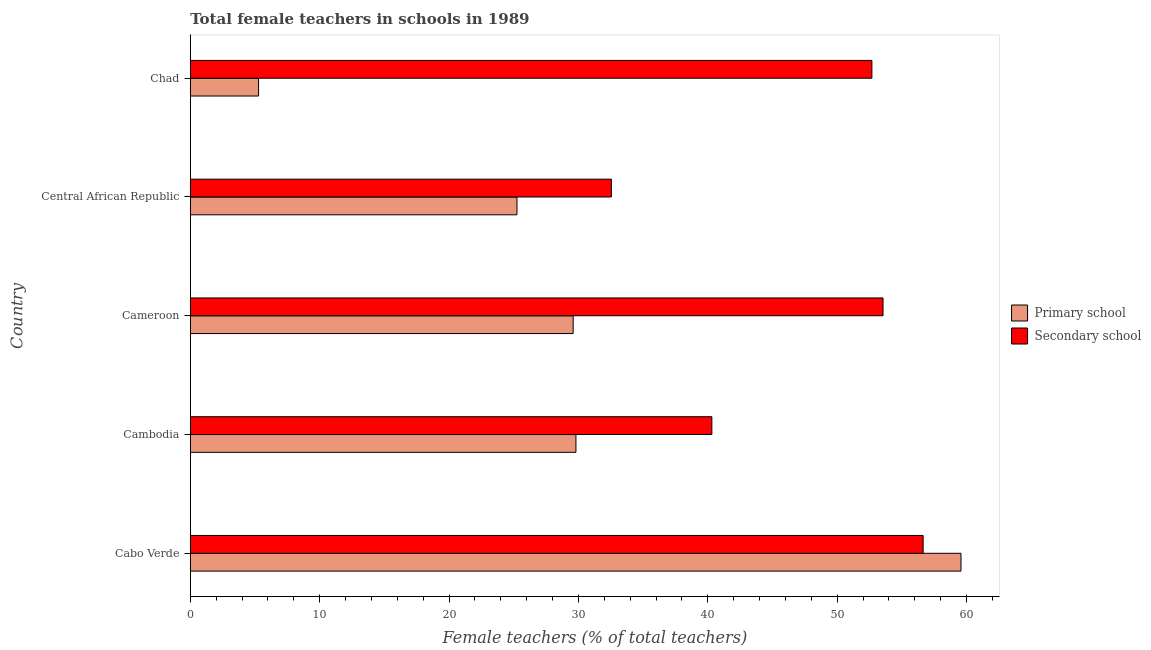Are the number of bars on each tick of the Y-axis equal?
Ensure brevity in your answer.  Yes. How many bars are there on the 3rd tick from the top?
Provide a succinct answer. 2. What is the label of the 3rd group of bars from the top?
Keep it short and to the point. Cameroon. In how many cases, is the number of bars for a given country not equal to the number of legend labels?
Your response must be concise. 0. What is the percentage of female teachers in secondary schools in Chad?
Your answer should be very brief. 52.68. Across all countries, what is the maximum percentage of female teachers in secondary schools?
Ensure brevity in your answer.  56.64. Across all countries, what is the minimum percentage of female teachers in secondary schools?
Give a very brief answer. 32.54. In which country was the percentage of female teachers in primary schools maximum?
Give a very brief answer. Cabo Verde. In which country was the percentage of female teachers in primary schools minimum?
Give a very brief answer. Chad. What is the total percentage of female teachers in primary schools in the graph?
Keep it short and to the point. 149.49. What is the difference between the percentage of female teachers in primary schools in Cameroon and that in Chad?
Offer a terse response. 24.31. What is the difference between the percentage of female teachers in secondary schools in Central African Republic and the percentage of female teachers in primary schools in Cambodia?
Provide a succinct answer. 2.74. What is the average percentage of female teachers in primary schools per country?
Provide a short and direct response. 29.9. What is the difference between the percentage of female teachers in primary schools and percentage of female teachers in secondary schools in Chad?
Offer a very short reply. -47.4. In how many countries, is the percentage of female teachers in primary schools greater than 6 %?
Provide a succinct answer. 4. What is the ratio of the percentage of female teachers in primary schools in Cabo Verde to that in Central African Republic?
Provide a short and direct response. 2.36. Is the percentage of female teachers in secondary schools in Cabo Verde less than that in Chad?
Your response must be concise. No. What is the difference between the highest and the lowest percentage of female teachers in secondary schools?
Offer a terse response. 24.1. In how many countries, is the percentage of female teachers in secondary schools greater than the average percentage of female teachers in secondary schools taken over all countries?
Your answer should be very brief. 3. Is the sum of the percentage of female teachers in primary schools in Central African Republic and Chad greater than the maximum percentage of female teachers in secondary schools across all countries?
Your answer should be compact. No. What does the 2nd bar from the top in Chad represents?
Offer a terse response. Primary school. What does the 1st bar from the bottom in Chad represents?
Your answer should be very brief. Primary school. How many bars are there?
Make the answer very short. 10. Are all the bars in the graph horizontal?
Offer a terse response. Yes. What is the difference between two consecutive major ticks on the X-axis?
Your response must be concise. 10. Are the values on the major ticks of X-axis written in scientific E-notation?
Give a very brief answer. No. Does the graph contain any zero values?
Your answer should be very brief. No. Does the graph contain grids?
Your response must be concise. No. Where does the legend appear in the graph?
Your response must be concise. Center right. How are the legend labels stacked?
Offer a very short reply. Vertical. What is the title of the graph?
Your answer should be very brief. Total female teachers in schools in 1989. What is the label or title of the X-axis?
Provide a short and direct response. Female teachers (% of total teachers). What is the Female teachers (% of total teachers) in Primary school in Cabo Verde?
Offer a terse response. 59.57. What is the Female teachers (% of total teachers) in Secondary school in Cabo Verde?
Your answer should be compact. 56.64. What is the Female teachers (% of total teachers) of Primary school in Cambodia?
Your answer should be very brief. 29.81. What is the Female teachers (% of total teachers) of Secondary school in Cambodia?
Provide a short and direct response. 40.31. What is the Female teachers (% of total teachers) in Primary school in Cameroon?
Keep it short and to the point. 29.59. What is the Female teachers (% of total teachers) of Secondary school in Cameroon?
Ensure brevity in your answer.  53.54. What is the Female teachers (% of total teachers) in Primary school in Central African Republic?
Provide a short and direct response. 25.25. What is the Female teachers (% of total teachers) in Secondary school in Central African Republic?
Offer a very short reply. 32.54. What is the Female teachers (% of total teachers) of Primary school in Chad?
Give a very brief answer. 5.28. What is the Female teachers (% of total teachers) of Secondary school in Chad?
Provide a short and direct response. 52.68. Across all countries, what is the maximum Female teachers (% of total teachers) of Primary school?
Offer a terse response. 59.57. Across all countries, what is the maximum Female teachers (% of total teachers) of Secondary school?
Your answer should be very brief. 56.64. Across all countries, what is the minimum Female teachers (% of total teachers) of Primary school?
Your answer should be very brief. 5.28. Across all countries, what is the minimum Female teachers (% of total teachers) in Secondary school?
Offer a very short reply. 32.54. What is the total Female teachers (% of total teachers) in Primary school in the graph?
Your response must be concise. 149.49. What is the total Female teachers (% of total teachers) of Secondary school in the graph?
Your answer should be very brief. 235.71. What is the difference between the Female teachers (% of total teachers) in Primary school in Cabo Verde and that in Cambodia?
Offer a terse response. 29.76. What is the difference between the Female teachers (% of total teachers) of Secondary school in Cabo Verde and that in Cambodia?
Offer a terse response. 16.33. What is the difference between the Female teachers (% of total teachers) in Primary school in Cabo Verde and that in Cameroon?
Offer a terse response. 29.97. What is the difference between the Female teachers (% of total teachers) in Secondary school in Cabo Verde and that in Cameroon?
Make the answer very short. 3.1. What is the difference between the Female teachers (% of total teachers) of Primary school in Cabo Verde and that in Central African Republic?
Your answer should be compact. 34.32. What is the difference between the Female teachers (% of total teachers) in Secondary school in Cabo Verde and that in Central African Republic?
Make the answer very short. 24.1. What is the difference between the Female teachers (% of total teachers) of Primary school in Cabo Verde and that in Chad?
Provide a succinct answer. 54.29. What is the difference between the Female teachers (% of total teachers) of Secondary school in Cabo Verde and that in Chad?
Your answer should be compact. 3.96. What is the difference between the Female teachers (% of total teachers) in Primary school in Cambodia and that in Cameroon?
Offer a terse response. 0.21. What is the difference between the Female teachers (% of total teachers) of Secondary school in Cambodia and that in Cameroon?
Offer a very short reply. -13.23. What is the difference between the Female teachers (% of total teachers) of Primary school in Cambodia and that in Central African Republic?
Ensure brevity in your answer.  4.56. What is the difference between the Female teachers (% of total teachers) of Secondary school in Cambodia and that in Central African Republic?
Provide a succinct answer. 7.77. What is the difference between the Female teachers (% of total teachers) in Primary school in Cambodia and that in Chad?
Your answer should be compact. 24.53. What is the difference between the Female teachers (% of total teachers) in Secondary school in Cambodia and that in Chad?
Provide a short and direct response. -12.37. What is the difference between the Female teachers (% of total teachers) of Primary school in Cameroon and that in Central African Republic?
Offer a terse response. 4.34. What is the difference between the Female teachers (% of total teachers) of Secondary school in Cameroon and that in Central African Republic?
Give a very brief answer. 21. What is the difference between the Female teachers (% of total teachers) of Primary school in Cameroon and that in Chad?
Your answer should be very brief. 24.31. What is the difference between the Female teachers (% of total teachers) in Secondary school in Cameroon and that in Chad?
Provide a succinct answer. 0.86. What is the difference between the Female teachers (% of total teachers) in Primary school in Central African Republic and that in Chad?
Give a very brief answer. 19.97. What is the difference between the Female teachers (% of total teachers) in Secondary school in Central African Republic and that in Chad?
Give a very brief answer. -20.14. What is the difference between the Female teachers (% of total teachers) of Primary school in Cabo Verde and the Female teachers (% of total teachers) of Secondary school in Cambodia?
Give a very brief answer. 19.26. What is the difference between the Female teachers (% of total teachers) in Primary school in Cabo Verde and the Female teachers (% of total teachers) in Secondary school in Cameroon?
Your response must be concise. 6.03. What is the difference between the Female teachers (% of total teachers) of Primary school in Cabo Verde and the Female teachers (% of total teachers) of Secondary school in Central African Republic?
Give a very brief answer. 27.02. What is the difference between the Female teachers (% of total teachers) in Primary school in Cabo Verde and the Female teachers (% of total teachers) in Secondary school in Chad?
Give a very brief answer. 6.89. What is the difference between the Female teachers (% of total teachers) of Primary school in Cambodia and the Female teachers (% of total teachers) of Secondary school in Cameroon?
Ensure brevity in your answer.  -23.73. What is the difference between the Female teachers (% of total teachers) of Primary school in Cambodia and the Female teachers (% of total teachers) of Secondary school in Central African Republic?
Give a very brief answer. -2.74. What is the difference between the Female teachers (% of total teachers) of Primary school in Cambodia and the Female teachers (% of total teachers) of Secondary school in Chad?
Keep it short and to the point. -22.87. What is the difference between the Female teachers (% of total teachers) in Primary school in Cameroon and the Female teachers (% of total teachers) in Secondary school in Central African Republic?
Offer a terse response. -2.95. What is the difference between the Female teachers (% of total teachers) in Primary school in Cameroon and the Female teachers (% of total teachers) in Secondary school in Chad?
Provide a short and direct response. -23.09. What is the difference between the Female teachers (% of total teachers) of Primary school in Central African Republic and the Female teachers (% of total teachers) of Secondary school in Chad?
Make the answer very short. -27.43. What is the average Female teachers (% of total teachers) of Primary school per country?
Offer a very short reply. 29.9. What is the average Female teachers (% of total teachers) in Secondary school per country?
Provide a succinct answer. 47.14. What is the difference between the Female teachers (% of total teachers) in Primary school and Female teachers (% of total teachers) in Secondary school in Cabo Verde?
Ensure brevity in your answer.  2.93. What is the difference between the Female teachers (% of total teachers) in Primary school and Female teachers (% of total teachers) in Secondary school in Cambodia?
Your response must be concise. -10.51. What is the difference between the Female teachers (% of total teachers) of Primary school and Female teachers (% of total teachers) of Secondary school in Cameroon?
Your answer should be compact. -23.95. What is the difference between the Female teachers (% of total teachers) of Primary school and Female teachers (% of total teachers) of Secondary school in Central African Republic?
Offer a very short reply. -7.3. What is the difference between the Female teachers (% of total teachers) in Primary school and Female teachers (% of total teachers) in Secondary school in Chad?
Offer a terse response. -47.4. What is the ratio of the Female teachers (% of total teachers) of Primary school in Cabo Verde to that in Cambodia?
Offer a terse response. 2. What is the ratio of the Female teachers (% of total teachers) in Secondary school in Cabo Verde to that in Cambodia?
Make the answer very short. 1.41. What is the ratio of the Female teachers (% of total teachers) of Primary school in Cabo Verde to that in Cameroon?
Your response must be concise. 2.01. What is the ratio of the Female teachers (% of total teachers) of Secondary school in Cabo Verde to that in Cameroon?
Your answer should be compact. 1.06. What is the ratio of the Female teachers (% of total teachers) in Primary school in Cabo Verde to that in Central African Republic?
Provide a succinct answer. 2.36. What is the ratio of the Female teachers (% of total teachers) in Secondary school in Cabo Verde to that in Central African Republic?
Offer a terse response. 1.74. What is the ratio of the Female teachers (% of total teachers) of Primary school in Cabo Verde to that in Chad?
Your response must be concise. 11.29. What is the ratio of the Female teachers (% of total teachers) of Secondary school in Cabo Verde to that in Chad?
Your answer should be very brief. 1.08. What is the ratio of the Female teachers (% of total teachers) in Secondary school in Cambodia to that in Cameroon?
Make the answer very short. 0.75. What is the ratio of the Female teachers (% of total teachers) of Primary school in Cambodia to that in Central African Republic?
Ensure brevity in your answer.  1.18. What is the ratio of the Female teachers (% of total teachers) in Secondary school in Cambodia to that in Central African Republic?
Make the answer very short. 1.24. What is the ratio of the Female teachers (% of total teachers) of Primary school in Cambodia to that in Chad?
Offer a terse response. 5.65. What is the ratio of the Female teachers (% of total teachers) of Secondary school in Cambodia to that in Chad?
Provide a succinct answer. 0.77. What is the ratio of the Female teachers (% of total teachers) in Primary school in Cameroon to that in Central African Republic?
Your answer should be very brief. 1.17. What is the ratio of the Female teachers (% of total teachers) of Secondary school in Cameroon to that in Central African Republic?
Your answer should be compact. 1.65. What is the ratio of the Female teachers (% of total teachers) in Primary school in Cameroon to that in Chad?
Offer a terse response. 5.61. What is the ratio of the Female teachers (% of total teachers) in Secondary school in Cameroon to that in Chad?
Ensure brevity in your answer.  1.02. What is the ratio of the Female teachers (% of total teachers) of Primary school in Central African Republic to that in Chad?
Make the answer very short. 4.78. What is the ratio of the Female teachers (% of total teachers) in Secondary school in Central African Republic to that in Chad?
Make the answer very short. 0.62. What is the difference between the highest and the second highest Female teachers (% of total teachers) of Primary school?
Make the answer very short. 29.76. What is the difference between the highest and the second highest Female teachers (% of total teachers) in Secondary school?
Provide a succinct answer. 3.1. What is the difference between the highest and the lowest Female teachers (% of total teachers) in Primary school?
Make the answer very short. 54.29. What is the difference between the highest and the lowest Female teachers (% of total teachers) in Secondary school?
Keep it short and to the point. 24.1. 